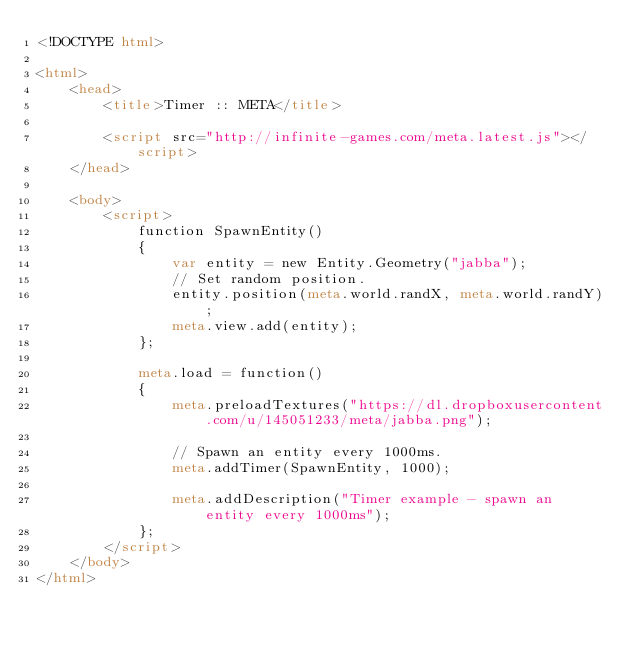Convert code to text. <code><loc_0><loc_0><loc_500><loc_500><_HTML_><!DOCTYPE html>

<html>
    <head>
        <title>Timer :: META</title>

        <script src="http://infinite-games.com/meta.latest.js"></script>
    </head>

    <body>
        <script>
            function SpawnEntity()
            {
                var entity = new Entity.Geometry("jabba");
                // Set random position.
                entity.position(meta.world.randX, meta.world.randY);
                meta.view.add(entity);
            };

            meta.load = function()
            {
                meta.preloadTextures("https://dl.dropboxusercontent.com/u/145051233/meta/jabba.png");

                // Spawn an entity every 1000ms.
                meta.addTimer(SpawnEntity, 1000);

                meta.addDescription("Timer example - spawn an entity every 1000ms"); 
            };
        </script>
    </body>
</html></code> 